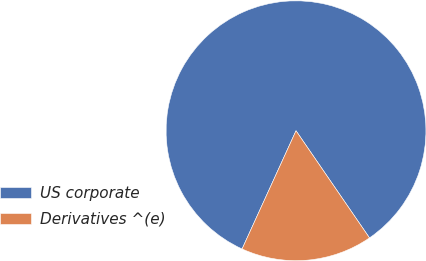Convert chart to OTSL. <chart><loc_0><loc_0><loc_500><loc_500><pie_chart><fcel>US corporate<fcel>Derivatives ^(e)<nl><fcel>83.62%<fcel>16.38%<nl></chart> 